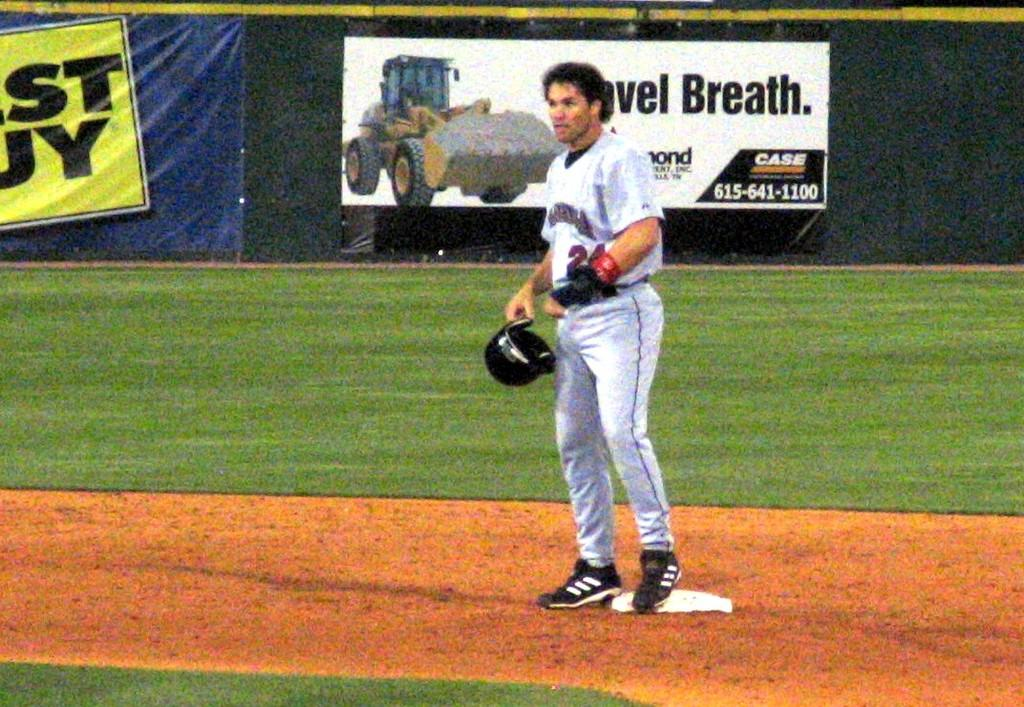<image>
Render a clear and concise summary of the photo. A baseball player stands on the base in front of a sign with the word breath on it. 